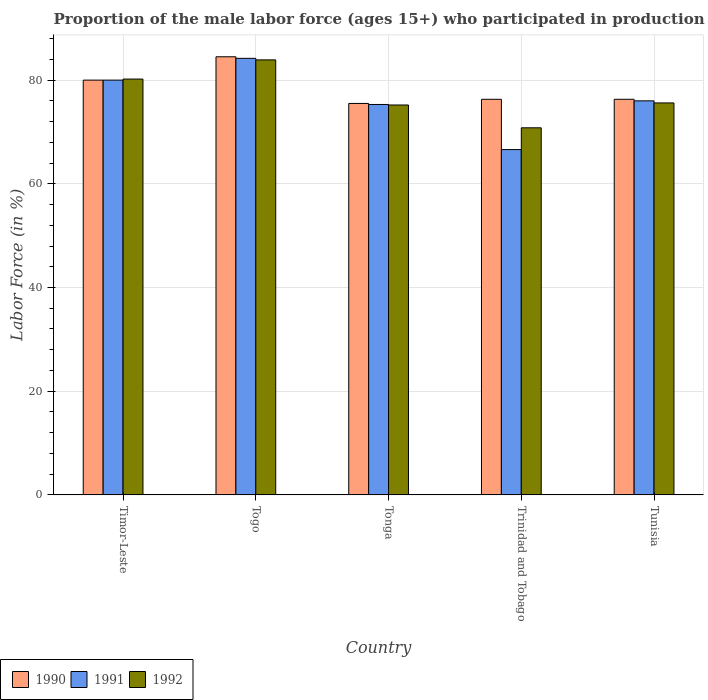How many different coloured bars are there?
Your answer should be very brief. 3. How many groups of bars are there?
Your answer should be very brief. 5. Are the number of bars per tick equal to the number of legend labels?
Provide a succinct answer. Yes. What is the label of the 5th group of bars from the left?
Your answer should be compact. Tunisia. What is the proportion of the male labor force who participated in production in 1991 in Tunisia?
Your answer should be compact. 76. Across all countries, what is the maximum proportion of the male labor force who participated in production in 1991?
Offer a terse response. 84.2. Across all countries, what is the minimum proportion of the male labor force who participated in production in 1991?
Give a very brief answer. 66.6. In which country was the proportion of the male labor force who participated in production in 1991 maximum?
Offer a terse response. Togo. In which country was the proportion of the male labor force who participated in production in 1991 minimum?
Your response must be concise. Trinidad and Tobago. What is the total proportion of the male labor force who participated in production in 1990 in the graph?
Your response must be concise. 392.6. What is the difference between the proportion of the male labor force who participated in production in 1991 in Timor-Leste and that in Tonga?
Your answer should be very brief. 4.7. What is the average proportion of the male labor force who participated in production in 1992 per country?
Offer a very short reply. 77.14. What is the difference between the proportion of the male labor force who participated in production of/in 1990 and proportion of the male labor force who participated in production of/in 1991 in Timor-Leste?
Provide a succinct answer. 0. What is the ratio of the proportion of the male labor force who participated in production in 1992 in Trinidad and Tobago to that in Tunisia?
Provide a succinct answer. 0.94. Is the proportion of the male labor force who participated in production in 1991 in Timor-Leste less than that in Trinidad and Tobago?
Give a very brief answer. No. Is the difference between the proportion of the male labor force who participated in production in 1990 in Togo and Tonga greater than the difference between the proportion of the male labor force who participated in production in 1991 in Togo and Tonga?
Provide a short and direct response. Yes. What is the difference between the highest and the second highest proportion of the male labor force who participated in production in 1991?
Your answer should be very brief. -4.2. What is the difference between the highest and the lowest proportion of the male labor force who participated in production in 1990?
Keep it short and to the point. 9. In how many countries, is the proportion of the male labor force who participated in production in 1990 greater than the average proportion of the male labor force who participated in production in 1990 taken over all countries?
Ensure brevity in your answer.  2. Is the sum of the proportion of the male labor force who participated in production in 1990 in Tonga and Tunisia greater than the maximum proportion of the male labor force who participated in production in 1991 across all countries?
Make the answer very short. Yes. What does the 1st bar from the left in Togo represents?
Provide a succinct answer. 1990. Is it the case that in every country, the sum of the proportion of the male labor force who participated in production in 1992 and proportion of the male labor force who participated in production in 1990 is greater than the proportion of the male labor force who participated in production in 1991?
Give a very brief answer. Yes. How many bars are there?
Your response must be concise. 15. Are all the bars in the graph horizontal?
Provide a short and direct response. No. How many countries are there in the graph?
Offer a very short reply. 5. Are the values on the major ticks of Y-axis written in scientific E-notation?
Offer a terse response. No. Does the graph contain any zero values?
Your response must be concise. No. How many legend labels are there?
Provide a short and direct response. 3. What is the title of the graph?
Provide a short and direct response. Proportion of the male labor force (ages 15+) who participated in production. What is the label or title of the X-axis?
Keep it short and to the point. Country. What is the label or title of the Y-axis?
Keep it short and to the point. Labor Force (in %). What is the Labor Force (in %) in 1992 in Timor-Leste?
Provide a short and direct response. 80.2. What is the Labor Force (in %) in 1990 in Togo?
Make the answer very short. 84.5. What is the Labor Force (in %) of 1991 in Togo?
Provide a short and direct response. 84.2. What is the Labor Force (in %) of 1992 in Togo?
Ensure brevity in your answer.  83.9. What is the Labor Force (in %) in 1990 in Tonga?
Offer a very short reply. 75.5. What is the Labor Force (in %) in 1991 in Tonga?
Your answer should be compact. 75.3. What is the Labor Force (in %) of 1992 in Tonga?
Your answer should be very brief. 75.2. What is the Labor Force (in %) of 1990 in Trinidad and Tobago?
Make the answer very short. 76.3. What is the Labor Force (in %) of 1991 in Trinidad and Tobago?
Offer a very short reply. 66.6. What is the Labor Force (in %) of 1992 in Trinidad and Tobago?
Provide a short and direct response. 70.8. What is the Labor Force (in %) in 1990 in Tunisia?
Ensure brevity in your answer.  76.3. What is the Labor Force (in %) of 1991 in Tunisia?
Your answer should be compact. 76. What is the Labor Force (in %) of 1992 in Tunisia?
Your answer should be very brief. 75.6. Across all countries, what is the maximum Labor Force (in %) in 1990?
Ensure brevity in your answer.  84.5. Across all countries, what is the maximum Labor Force (in %) of 1991?
Ensure brevity in your answer.  84.2. Across all countries, what is the maximum Labor Force (in %) of 1992?
Your answer should be very brief. 83.9. Across all countries, what is the minimum Labor Force (in %) of 1990?
Ensure brevity in your answer.  75.5. Across all countries, what is the minimum Labor Force (in %) of 1991?
Make the answer very short. 66.6. Across all countries, what is the minimum Labor Force (in %) in 1992?
Your response must be concise. 70.8. What is the total Labor Force (in %) of 1990 in the graph?
Ensure brevity in your answer.  392.6. What is the total Labor Force (in %) in 1991 in the graph?
Offer a very short reply. 382.1. What is the total Labor Force (in %) of 1992 in the graph?
Offer a terse response. 385.7. What is the difference between the Labor Force (in %) of 1990 in Timor-Leste and that in Togo?
Provide a short and direct response. -4.5. What is the difference between the Labor Force (in %) in 1992 in Timor-Leste and that in Togo?
Provide a short and direct response. -3.7. What is the difference between the Labor Force (in %) of 1992 in Timor-Leste and that in Tonga?
Provide a short and direct response. 5. What is the difference between the Labor Force (in %) in 1990 in Timor-Leste and that in Trinidad and Tobago?
Make the answer very short. 3.7. What is the difference between the Labor Force (in %) in 1991 in Timor-Leste and that in Trinidad and Tobago?
Offer a terse response. 13.4. What is the difference between the Labor Force (in %) in 1990 in Timor-Leste and that in Tunisia?
Make the answer very short. 3.7. What is the difference between the Labor Force (in %) of 1991 in Timor-Leste and that in Tunisia?
Ensure brevity in your answer.  4. What is the difference between the Labor Force (in %) in 1992 in Timor-Leste and that in Tunisia?
Offer a very short reply. 4.6. What is the difference between the Labor Force (in %) of 1991 in Togo and that in Tonga?
Provide a succinct answer. 8.9. What is the difference between the Labor Force (in %) of 1991 in Togo and that in Trinidad and Tobago?
Provide a short and direct response. 17.6. What is the difference between the Labor Force (in %) of 1990 in Togo and that in Tunisia?
Your answer should be compact. 8.2. What is the difference between the Labor Force (in %) in 1992 in Togo and that in Tunisia?
Offer a terse response. 8.3. What is the difference between the Labor Force (in %) in 1990 in Tonga and that in Trinidad and Tobago?
Provide a short and direct response. -0.8. What is the difference between the Labor Force (in %) in 1992 in Tonga and that in Trinidad and Tobago?
Provide a short and direct response. 4.4. What is the difference between the Labor Force (in %) in 1990 in Tonga and that in Tunisia?
Offer a terse response. -0.8. What is the difference between the Labor Force (in %) in 1991 in Tonga and that in Tunisia?
Ensure brevity in your answer.  -0.7. What is the difference between the Labor Force (in %) in 1991 in Trinidad and Tobago and that in Tunisia?
Give a very brief answer. -9.4. What is the difference between the Labor Force (in %) of 1990 in Timor-Leste and the Labor Force (in %) of 1992 in Togo?
Provide a succinct answer. -3.9. What is the difference between the Labor Force (in %) in 1990 in Timor-Leste and the Labor Force (in %) in 1992 in Trinidad and Tobago?
Provide a succinct answer. 9.2. What is the difference between the Labor Force (in %) in 1991 in Timor-Leste and the Labor Force (in %) in 1992 in Trinidad and Tobago?
Your response must be concise. 9.2. What is the difference between the Labor Force (in %) in 1990 in Timor-Leste and the Labor Force (in %) in 1991 in Tunisia?
Keep it short and to the point. 4. What is the difference between the Labor Force (in %) in 1990 in Togo and the Labor Force (in %) in 1991 in Tonga?
Give a very brief answer. 9.2. What is the difference between the Labor Force (in %) of 1991 in Togo and the Labor Force (in %) of 1992 in Tonga?
Provide a succinct answer. 9. What is the difference between the Labor Force (in %) in 1990 in Togo and the Labor Force (in %) in 1991 in Trinidad and Tobago?
Give a very brief answer. 17.9. What is the difference between the Labor Force (in %) in 1990 in Togo and the Labor Force (in %) in 1992 in Tunisia?
Offer a terse response. 8.9. What is the difference between the Labor Force (in %) of 1990 in Tonga and the Labor Force (in %) of 1992 in Tunisia?
Offer a very short reply. -0.1. What is the difference between the Labor Force (in %) of 1991 in Tonga and the Labor Force (in %) of 1992 in Tunisia?
Make the answer very short. -0.3. What is the average Labor Force (in %) in 1990 per country?
Provide a short and direct response. 78.52. What is the average Labor Force (in %) of 1991 per country?
Give a very brief answer. 76.42. What is the average Labor Force (in %) of 1992 per country?
Ensure brevity in your answer.  77.14. What is the difference between the Labor Force (in %) of 1991 and Labor Force (in %) of 1992 in Timor-Leste?
Ensure brevity in your answer.  -0.2. What is the difference between the Labor Force (in %) of 1990 and Labor Force (in %) of 1991 in Togo?
Your response must be concise. 0.3. What is the difference between the Labor Force (in %) of 1990 and Labor Force (in %) of 1991 in Tonga?
Keep it short and to the point. 0.2. What is the difference between the Labor Force (in %) in 1990 and Labor Force (in %) in 1992 in Tonga?
Provide a short and direct response. 0.3. What is the difference between the Labor Force (in %) of 1991 and Labor Force (in %) of 1992 in Tonga?
Provide a succinct answer. 0.1. What is the difference between the Labor Force (in %) of 1990 and Labor Force (in %) of 1991 in Trinidad and Tobago?
Provide a succinct answer. 9.7. What is the difference between the Labor Force (in %) of 1990 and Labor Force (in %) of 1992 in Trinidad and Tobago?
Offer a terse response. 5.5. What is the difference between the Labor Force (in %) in 1991 and Labor Force (in %) in 1992 in Trinidad and Tobago?
Give a very brief answer. -4.2. What is the difference between the Labor Force (in %) in 1990 and Labor Force (in %) in 1991 in Tunisia?
Your answer should be compact. 0.3. What is the difference between the Labor Force (in %) in 1990 and Labor Force (in %) in 1992 in Tunisia?
Your answer should be compact. 0.7. What is the difference between the Labor Force (in %) of 1991 and Labor Force (in %) of 1992 in Tunisia?
Offer a very short reply. 0.4. What is the ratio of the Labor Force (in %) of 1990 in Timor-Leste to that in Togo?
Provide a succinct answer. 0.95. What is the ratio of the Labor Force (in %) in 1991 in Timor-Leste to that in Togo?
Keep it short and to the point. 0.95. What is the ratio of the Labor Force (in %) in 1992 in Timor-Leste to that in Togo?
Your answer should be compact. 0.96. What is the ratio of the Labor Force (in %) in 1990 in Timor-Leste to that in Tonga?
Your response must be concise. 1.06. What is the ratio of the Labor Force (in %) in 1991 in Timor-Leste to that in Tonga?
Your answer should be compact. 1.06. What is the ratio of the Labor Force (in %) of 1992 in Timor-Leste to that in Tonga?
Your answer should be compact. 1.07. What is the ratio of the Labor Force (in %) of 1990 in Timor-Leste to that in Trinidad and Tobago?
Offer a terse response. 1.05. What is the ratio of the Labor Force (in %) in 1991 in Timor-Leste to that in Trinidad and Tobago?
Your answer should be very brief. 1.2. What is the ratio of the Labor Force (in %) in 1992 in Timor-Leste to that in Trinidad and Tobago?
Offer a terse response. 1.13. What is the ratio of the Labor Force (in %) in 1990 in Timor-Leste to that in Tunisia?
Offer a very short reply. 1.05. What is the ratio of the Labor Force (in %) of 1991 in Timor-Leste to that in Tunisia?
Ensure brevity in your answer.  1.05. What is the ratio of the Labor Force (in %) of 1992 in Timor-Leste to that in Tunisia?
Your response must be concise. 1.06. What is the ratio of the Labor Force (in %) of 1990 in Togo to that in Tonga?
Your response must be concise. 1.12. What is the ratio of the Labor Force (in %) of 1991 in Togo to that in Tonga?
Provide a short and direct response. 1.12. What is the ratio of the Labor Force (in %) in 1992 in Togo to that in Tonga?
Ensure brevity in your answer.  1.12. What is the ratio of the Labor Force (in %) in 1990 in Togo to that in Trinidad and Tobago?
Provide a short and direct response. 1.11. What is the ratio of the Labor Force (in %) in 1991 in Togo to that in Trinidad and Tobago?
Make the answer very short. 1.26. What is the ratio of the Labor Force (in %) of 1992 in Togo to that in Trinidad and Tobago?
Provide a succinct answer. 1.19. What is the ratio of the Labor Force (in %) in 1990 in Togo to that in Tunisia?
Your response must be concise. 1.11. What is the ratio of the Labor Force (in %) in 1991 in Togo to that in Tunisia?
Provide a short and direct response. 1.11. What is the ratio of the Labor Force (in %) in 1992 in Togo to that in Tunisia?
Offer a very short reply. 1.11. What is the ratio of the Labor Force (in %) of 1991 in Tonga to that in Trinidad and Tobago?
Provide a succinct answer. 1.13. What is the ratio of the Labor Force (in %) in 1992 in Tonga to that in Trinidad and Tobago?
Make the answer very short. 1.06. What is the ratio of the Labor Force (in %) of 1991 in Tonga to that in Tunisia?
Your answer should be very brief. 0.99. What is the ratio of the Labor Force (in %) in 1992 in Tonga to that in Tunisia?
Provide a succinct answer. 0.99. What is the ratio of the Labor Force (in %) in 1990 in Trinidad and Tobago to that in Tunisia?
Your answer should be very brief. 1. What is the ratio of the Labor Force (in %) in 1991 in Trinidad and Tobago to that in Tunisia?
Your answer should be compact. 0.88. What is the ratio of the Labor Force (in %) in 1992 in Trinidad and Tobago to that in Tunisia?
Your answer should be compact. 0.94. What is the difference between the highest and the lowest Labor Force (in %) in 1991?
Provide a succinct answer. 17.6. What is the difference between the highest and the lowest Labor Force (in %) in 1992?
Offer a terse response. 13.1. 